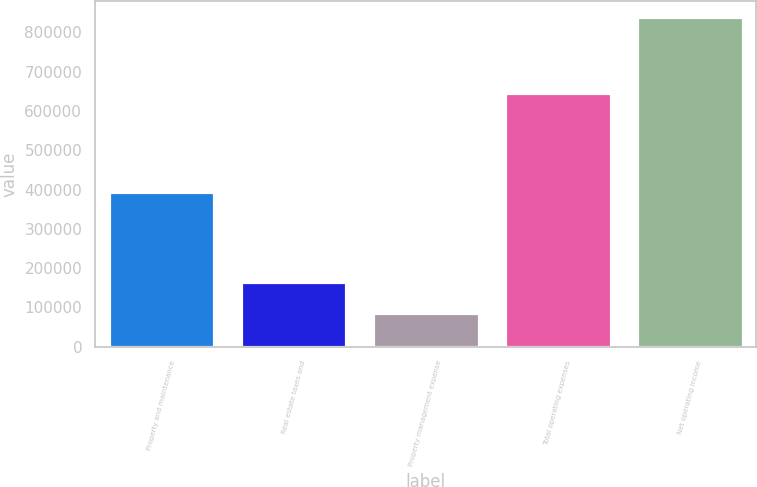Convert chart to OTSL. <chart><loc_0><loc_0><loc_500><loc_500><bar_chart><fcel>Property and maintenance<fcel>Real estate taxes and<fcel>Property management expense<fcel>Total operating expenses<fcel>Net operating income<nl><fcel>394850<fcel>165248<fcel>86873<fcel>646971<fcel>838299<nl></chart> 